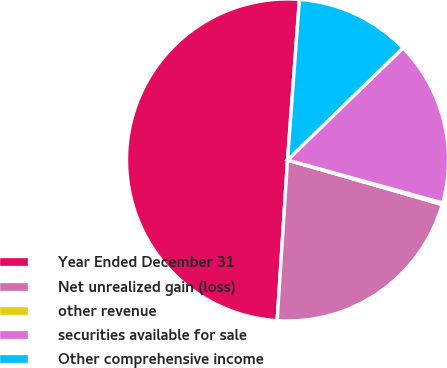Convert chart. <chart><loc_0><loc_0><loc_500><loc_500><pie_chart><fcel>Year Ended December 31<fcel>Net unrealized gain (loss)<fcel>other revenue<fcel>securities available for sale<fcel>Other comprehensive income<nl><fcel>50.15%<fcel>21.56%<fcel>0.17%<fcel>16.56%<fcel>11.56%<nl></chart> 